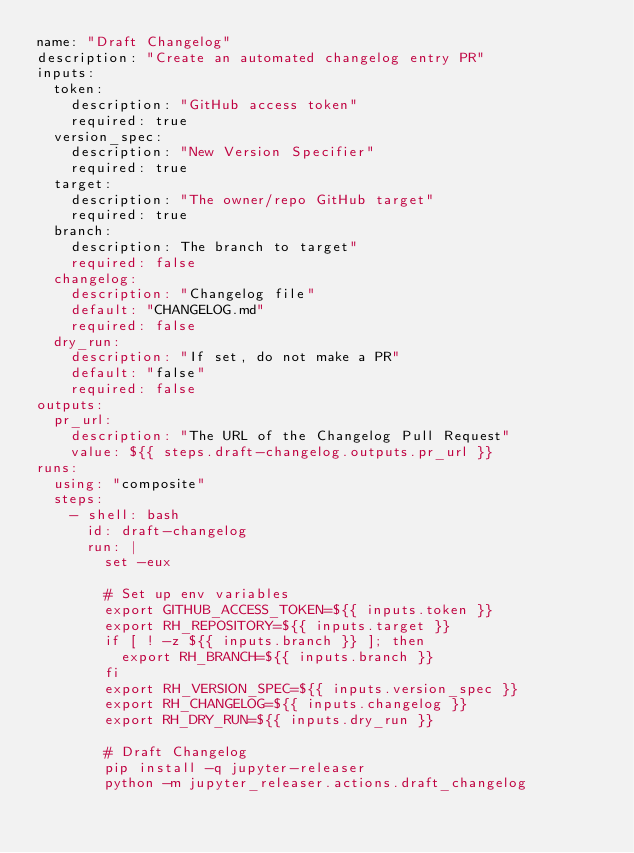Convert code to text. <code><loc_0><loc_0><loc_500><loc_500><_YAML_>name: "Draft Changelog"
description: "Create an automated changelog entry PR"
inputs:
  token:
    description: "GitHub access token"
    required: true
  version_spec:
    description: "New Version Specifier"
    required: true
  target:
    description: "The owner/repo GitHub target"
    required: true
  branch:
    description: The branch to target"
    required: false
  changelog:
    description: "Changelog file"
    default: "CHANGELOG.md"
    required: false
  dry_run:
    description: "If set, do not make a PR"
    default: "false"
    required: false
outputs:
  pr_url:
    description: "The URL of the Changelog Pull Request"
    value: ${{ steps.draft-changelog.outputs.pr_url }}
runs:
  using: "composite"
  steps:
    - shell: bash
      id: draft-changelog
      run: |
        set -eux

        # Set up env variables
        export GITHUB_ACCESS_TOKEN=${{ inputs.token }}
        export RH_REPOSITORY=${{ inputs.target }}
        if [ ! -z ${{ inputs.branch }} ]; then
          export RH_BRANCH=${{ inputs.branch }}
        fi
        export RH_VERSION_SPEC=${{ inputs.version_spec }}
        export RH_CHANGELOG=${{ inputs.changelog }}
        export RH_DRY_RUN=${{ inputs.dry_run }}

        # Draft Changelog
        pip install -q jupyter-releaser
        python -m jupyter_releaser.actions.draft_changelog
</code> 